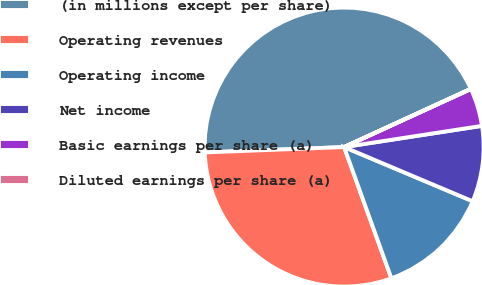<chart> <loc_0><loc_0><loc_500><loc_500><pie_chart><fcel>(in millions except per share)<fcel>Operating revenues<fcel>Operating income<fcel>Net income<fcel>Basic earnings per share (a)<fcel>Diluted earnings per share (a)<nl><fcel>43.75%<fcel>29.89%<fcel>13.15%<fcel>8.78%<fcel>4.4%<fcel>0.03%<nl></chart> 